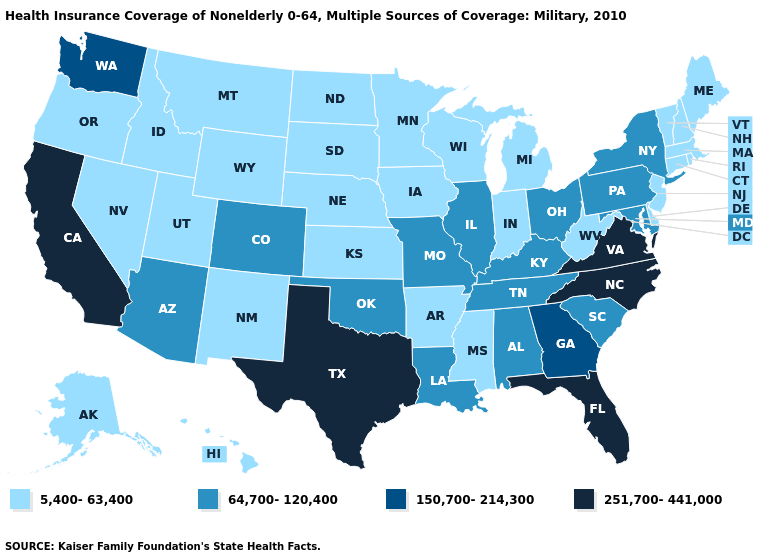Does Vermont have the lowest value in the USA?
Answer briefly. Yes. Among the states that border Connecticut , does New York have the highest value?
Quick response, please. Yes. What is the highest value in the USA?
Quick response, please. 251,700-441,000. Does the first symbol in the legend represent the smallest category?
Keep it brief. Yes. Does Delaware have the same value as Mississippi?
Short answer required. Yes. Name the states that have a value in the range 150,700-214,300?
Be succinct. Georgia, Washington. What is the highest value in the USA?
Concise answer only. 251,700-441,000. Does New York have the lowest value in the Northeast?
Concise answer only. No. What is the value of New York?
Give a very brief answer. 64,700-120,400. Name the states that have a value in the range 5,400-63,400?
Be succinct. Alaska, Arkansas, Connecticut, Delaware, Hawaii, Idaho, Indiana, Iowa, Kansas, Maine, Massachusetts, Michigan, Minnesota, Mississippi, Montana, Nebraska, Nevada, New Hampshire, New Jersey, New Mexico, North Dakota, Oregon, Rhode Island, South Dakota, Utah, Vermont, West Virginia, Wisconsin, Wyoming. Does Florida have the highest value in the USA?
Answer briefly. Yes. What is the value of Oregon?
Keep it brief. 5,400-63,400. What is the value of Missouri?
Short answer required. 64,700-120,400. Which states hav the highest value in the West?
Answer briefly. California. Which states have the highest value in the USA?
Concise answer only. California, Florida, North Carolina, Texas, Virginia. 